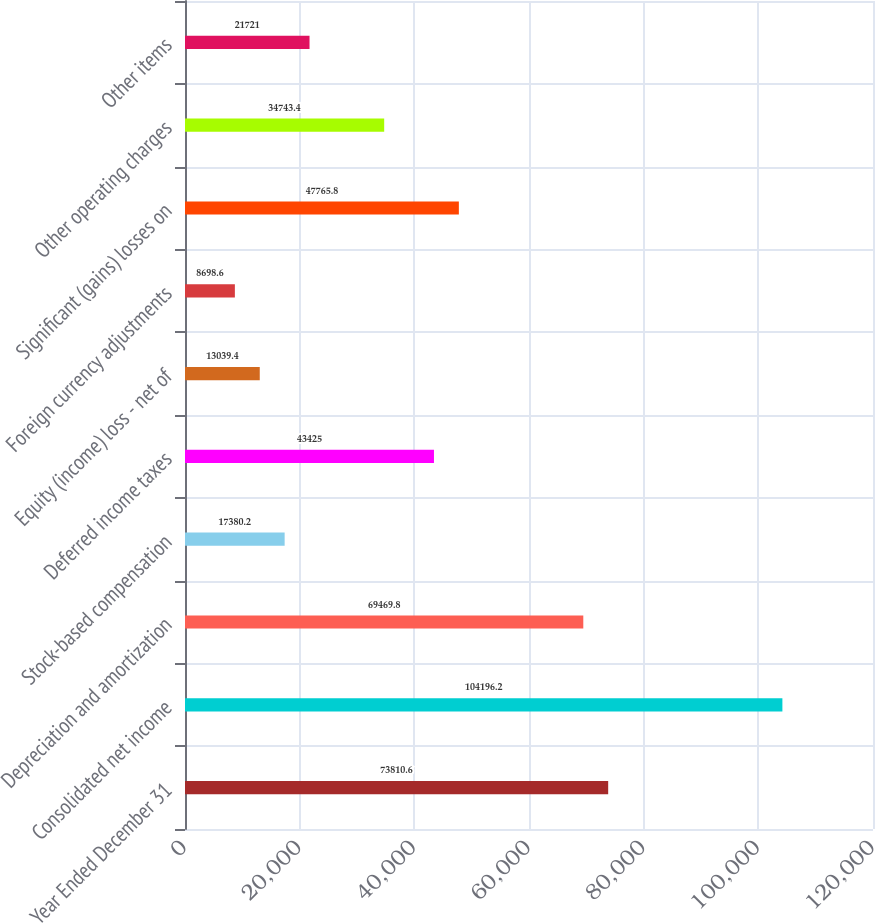<chart> <loc_0><loc_0><loc_500><loc_500><bar_chart><fcel>Year Ended December 31<fcel>Consolidated net income<fcel>Depreciation and amortization<fcel>Stock-based compensation<fcel>Deferred income taxes<fcel>Equity (income) loss - net of<fcel>Foreign currency adjustments<fcel>Significant (gains) losses on<fcel>Other operating charges<fcel>Other items<nl><fcel>73810.6<fcel>104196<fcel>69469.8<fcel>17380.2<fcel>43425<fcel>13039.4<fcel>8698.6<fcel>47765.8<fcel>34743.4<fcel>21721<nl></chart> 